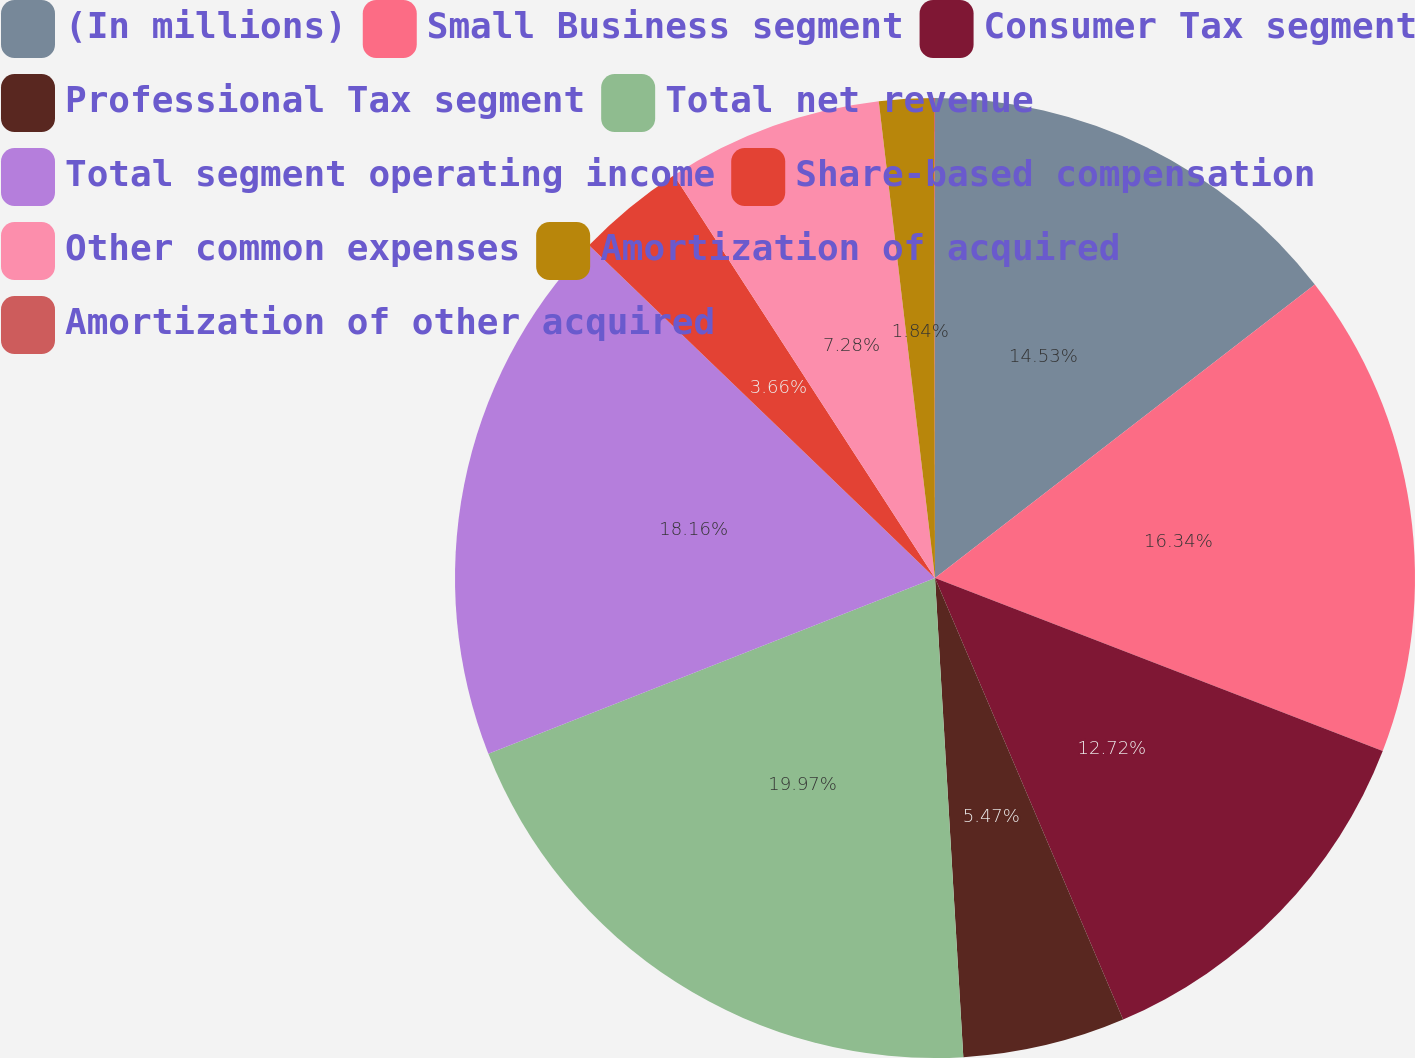Convert chart. <chart><loc_0><loc_0><loc_500><loc_500><pie_chart><fcel>(In millions)<fcel>Small Business segment<fcel>Consumer Tax segment<fcel>Professional Tax segment<fcel>Total net revenue<fcel>Total segment operating income<fcel>Share-based compensation<fcel>Other common expenses<fcel>Amortization of acquired<fcel>Amortization of other acquired<nl><fcel>14.53%<fcel>16.34%<fcel>12.72%<fcel>5.47%<fcel>19.97%<fcel>18.16%<fcel>3.66%<fcel>7.28%<fcel>1.84%<fcel>0.03%<nl></chart> 